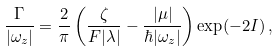<formula> <loc_0><loc_0><loc_500><loc_500>\frac { \Gamma } { | \omega _ { z } | } = \frac { 2 } { \pi } \left ( \frac { \zeta } { F | \lambda | } - \frac { | \mu | } { \hbar { | } \omega _ { z } | } \right ) \exp ( - 2 I ) \, ,</formula> 